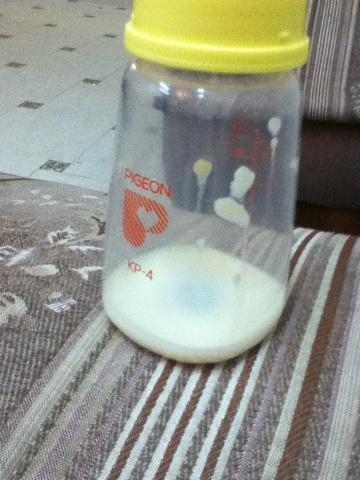Is this type of bottle easy to clean? Yes, this type of bottle is typically easy to clean. It has a wide opening that allows for thorough scrubbing and is usually made of materials that are safe to sterilize, making it convenient for parents to maintain hygiene. 